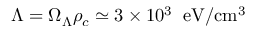<formula> <loc_0><loc_0><loc_500><loc_500>\Lambda = \Omega _ { \Lambda } \rho _ { c } \simeq 3 \times 1 0 ^ { 3 } \, e V / \mathrm { c m } ^ { 3 }</formula> 